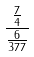Convert formula to latex. <formula><loc_0><loc_0><loc_500><loc_500>\frac { \frac { 7 } { 4 } } { \frac { 6 } { 3 7 7 } }</formula> 